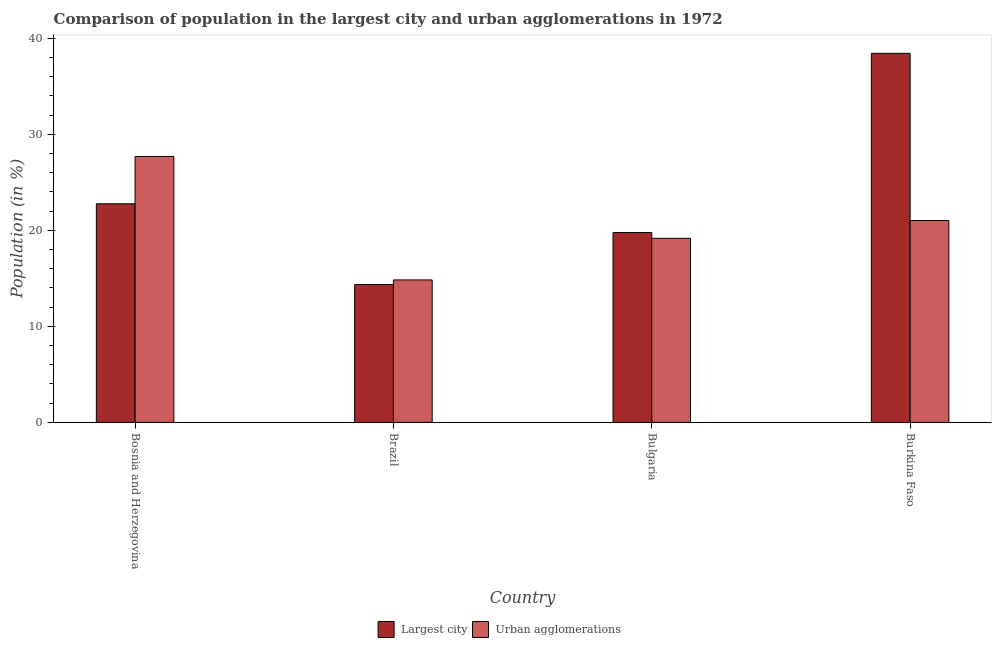How many different coloured bars are there?
Offer a terse response. 2. Are the number of bars on each tick of the X-axis equal?
Provide a short and direct response. Yes. How many bars are there on the 2nd tick from the left?
Your answer should be compact. 2. How many bars are there on the 2nd tick from the right?
Give a very brief answer. 2. What is the label of the 3rd group of bars from the left?
Provide a succinct answer. Bulgaria. What is the population in the largest city in Burkina Faso?
Keep it short and to the point. 38.44. Across all countries, what is the maximum population in the largest city?
Your answer should be very brief. 38.44. Across all countries, what is the minimum population in urban agglomerations?
Your answer should be very brief. 14.84. In which country was the population in urban agglomerations maximum?
Your response must be concise. Bosnia and Herzegovina. What is the total population in the largest city in the graph?
Ensure brevity in your answer.  95.34. What is the difference between the population in urban agglomerations in Bosnia and Herzegovina and that in Burkina Faso?
Provide a short and direct response. 6.67. What is the difference between the population in the largest city in Bulgaria and the population in urban agglomerations in Bosnia and Herzegovina?
Provide a short and direct response. -7.92. What is the average population in the largest city per country?
Your answer should be compact. 23.83. What is the difference between the population in urban agglomerations and population in the largest city in Brazil?
Keep it short and to the point. 0.48. What is the ratio of the population in urban agglomerations in Bosnia and Herzegovina to that in Brazil?
Keep it short and to the point. 1.87. Is the difference between the population in urban agglomerations in Brazil and Burkina Faso greater than the difference between the population in the largest city in Brazil and Burkina Faso?
Ensure brevity in your answer.  Yes. What is the difference between the highest and the second highest population in the largest city?
Give a very brief answer. 15.67. What is the difference between the highest and the lowest population in the largest city?
Provide a succinct answer. 24.08. Is the sum of the population in urban agglomerations in Brazil and Bulgaria greater than the maximum population in the largest city across all countries?
Provide a succinct answer. No. What does the 1st bar from the left in Bulgaria represents?
Offer a terse response. Largest city. What does the 1st bar from the right in Bulgaria represents?
Your answer should be very brief. Urban agglomerations. How many bars are there?
Your answer should be very brief. 8. What is the difference between two consecutive major ticks on the Y-axis?
Offer a very short reply. 10. Are the values on the major ticks of Y-axis written in scientific E-notation?
Give a very brief answer. No. Does the graph contain grids?
Keep it short and to the point. No. Where does the legend appear in the graph?
Make the answer very short. Bottom center. How many legend labels are there?
Your answer should be very brief. 2. How are the legend labels stacked?
Provide a short and direct response. Horizontal. What is the title of the graph?
Your response must be concise. Comparison of population in the largest city and urban agglomerations in 1972. Does "Merchandise imports" appear as one of the legend labels in the graph?
Offer a terse response. No. What is the label or title of the X-axis?
Your answer should be very brief. Country. What is the label or title of the Y-axis?
Provide a succinct answer. Population (in %). What is the Population (in %) of Largest city in Bosnia and Herzegovina?
Your answer should be compact. 22.77. What is the Population (in %) of Urban agglomerations in Bosnia and Herzegovina?
Your response must be concise. 27.7. What is the Population (in %) in Largest city in Brazil?
Your response must be concise. 14.36. What is the Population (in %) in Urban agglomerations in Brazil?
Offer a terse response. 14.84. What is the Population (in %) in Largest city in Bulgaria?
Your answer should be very brief. 19.77. What is the Population (in %) of Urban agglomerations in Bulgaria?
Offer a terse response. 19.17. What is the Population (in %) of Largest city in Burkina Faso?
Make the answer very short. 38.44. What is the Population (in %) in Urban agglomerations in Burkina Faso?
Give a very brief answer. 21.02. Across all countries, what is the maximum Population (in %) in Largest city?
Provide a short and direct response. 38.44. Across all countries, what is the maximum Population (in %) of Urban agglomerations?
Your answer should be compact. 27.7. Across all countries, what is the minimum Population (in %) of Largest city?
Your response must be concise. 14.36. Across all countries, what is the minimum Population (in %) in Urban agglomerations?
Your response must be concise. 14.84. What is the total Population (in %) in Largest city in the graph?
Provide a short and direct response. 95.34. What is the total Population (in %) in Urban agglomerations in the graph?
Ensure brevity in your answer.  82.73. What is the difference between the Population (in %) of Largest city in Bosnia and Herzegovina and that in Brazil?
Your answer should be very brief. 8.41. What is the difference between the Population (in %) of Urban agglomerations in Bosnia and Herzegovina and that in Brazil?
Give a very brief answer. 12.86. What is the difference between the Population (in %) in Largest city in Bosnia and Herzegovina and that in Bulgaria?
Make the answer very short. 2.99. What is the difference between the Population (in %) of Urban agglomerations in Bosnia and Herzegovina and that in Bulgaria?
Ensure brevity in your answer.  8.53. What is the difference between the Population (in %) in Largest city in Bosnia and Herzegovina and that in Burkina Faso?
Keep it short and to the point. -15.67. What is the difference between the Population (in %) in Urban agglomerations in Bosnia and Herzegovina and that in Burkina Faso?
Your response must be concise. 6.67. What is the difference between the Population (in %) in Largest city in Brazil and that in Bulgaria?
Keep it short and to the point. -5.42. What is the difference between the Population (in %) in Urban agglomerations in Brazil and that in Bulgaria?
Provide a succinct answer. -4.33. What is the difference between the Population (in %) in Largest city in Brazil and that in Burkina Faso?
Keep it short and to the point. -24.08. What is the difference between the Population (in %) in Urban agglomerations in Brazil and that in Burkina Faso?
Ensure brevity in your answer.  -6.18. What is the difference between the Population (in %) of Largest city in Bulgaria and that in Burkina Faso?
Offer a terse response. -18.66. What is the difference between the Population (in %) in Urban agglomerations in Bulgaria and that in Burkina Faso?
Provide a succinct answer. -1.85. What is the difference between the Population (in %) of Largest city in Bosnia and Herzegovina and the Population (in %) of Urban agglomerations in Brazil?
Provide a succinct answer. 7.93. What is the difference between the Population (in %) in Largest city in Bosnia and Herzegovina and the Population (in %) in Urban agglomerations in Bulgaria?
Your answer should be very brief. 3.6. What is the difference between the Population (in %) of Largest city in Bosnia and Herzegovina and the Population (in %) of Urban agglomerations in Burkina Faso?
Provide a short and direct response. 1.74. What is the difference between the Population (in %) in Largest city in Brazil and the Population (in %) in Urban agglomerations in Bulgaria?
Offer a very short reply. -4.81. What is the difference between the Population (in %) of Largest city in Brazil and the Population (in %) of Urban agglomerations in Burkina Faso?
Provide a short and direct response. -6.67. What is the difference between the Population (in %) of Largest city in Bulgaria and the Population (in %) of Urban agglomerations in Burkina Faso?
Keep it short and to the point. -1.25. What is the average Population (in %) of Largest city per country?
Provide a short and direct response. 23.83. What is the average Population (in %) in Urban agglomerations per country?
Offer a terse response. 20.68. What is the difference between the Population (in %) in Largest city and Population (in %) in Urban agglomerations in Bosnia and Herzegovina?
Ensure brevity in your answer.  -4.93. What is the difference between the Population (in %) in Largest city and Population (in %) in Urban agglomerations in Brazil?
Offer a very short reply. -0.48. What is the difference between the Population (in %) of Largest city and Population (in %) of Urban agglomerations in Bulgaria?
Make the answer very short. 0.6. What is the difference between the Population (in %) of Largest city and Population (in %) of Urban agglomerations in Burkina Faso?
Your answer should be compact. 17.41. What is the ratio of the Population (in %) of Largest city in Bosnia and Herzegovina to that in Brazil?
Your response must be concise. 1.59. What is the ratio of the Population (in %) in Urban agglomerations in Bosnia and Herzegovina to that in Brazil?
Your answer should be compact. 1.87. What is the ratio of the Population (in %) in Largest city in Bosnia and Herzegovina to that in Bulgaria?
Ensure brevity in your answer.  1.15. What is the ratio of the Population (in %) in Urban agglomerations in Bosnia and Herzegovina to that in Bulgaria?
Provide a short and direct response. 1.44. What is the ratio of the Population (in %) of Largest city in Bosnia and Herzegovina to that in Burkina Faso?
Your answer should be compact. 0.59. What is the ratio of the Population (in %) in Urban agglomerations in Bosnia and Herzegovina to that in Burkina Faso?
Your answer should be very brief. 1.32. What is the ratio of the Population (in %) in Largest city in Brazil to that in Bulgaria?
Provide a succinct answer. 0.73. What is the ratio of the Population (in %) in Urban agglomerations in Brazil to that in Bulgaria?
Give a very brief answer. 0.77. What is the ratio of the Population (in %) in Largest city in Brazil to that in Burkina Faso?
Provide a succinct answer. 0.37. What is the ratio of the Population (in %) in Urban agglomerations in Brazil to that in Burkina Faso?
Provide a short and direct response. 0.71. What is the ratio of the Population (in %) of Largest city in Bulgaria to that in Burkina Faso?
Ensure brevity in your answer.  0.51. What is the ratio of the Population (in %) of Urban agglomerations in Bulgaria to that in Burkina Faso?
Provide a short and direct response. 0.91. What is the difference between the highest and the second highest Population (in %) in Largest city?
Your answer should be very brief. 15.67. What is the difference between the highest and the second highest Population (in %) of Urban agglomerations?
Your response must be concise. 6.67. What is the difference between the highest and the lowest Population (in %) in Largest city?
Offer a very short reply. 24.08. What is the difference between the highest and the lowest Population (in %) of Urban agglomerations?
Provide a succinct answer. 12.86. 